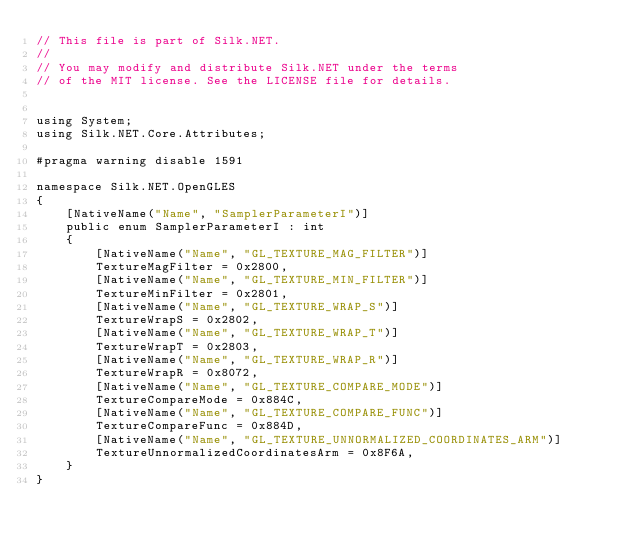<code> <loc_0><loc_0><loc_500><loc_500><_C#_>// This file is part of Silk.NET.
// 
// You may modify and distribute Silk.NET under the terms
// of the MIT license. See the LICENSE file for details.


using System;
using Silk.NET.Core.Attributes;

#pragma warning disable 1591

namespace Silk.NET.OpenGLES
{
    [NativeName("Name", "SamplerParameterI")]
    public enum SamplerParameterI : int
    {
        [NativeName("Name", "GL_TEXTURE_MAG_FILTER")]
        TextureMagFilter = 0x2800,
        [NativeName("Name", "GL_TEXTURE_MIN_FILTER")]
        TextureMinFilter = 0x2801,
        [NativeName("Name", "GL_TEXTURE_WRAP_S")]
        TextureWrapS = 0x2802,
        [NativeName("Name", "GL_TEXTURE_WRAP_T")]
        TextureWrapT = 0x2803,
        [NativeName("Name", "GL_TEXTURE_WRAP_R")]
        TextureWrapR = 0x8072,
        [NativeName("Name", "GL_TEXTURE_COMPARE_MODE")]
        TextureCompareMode = 0x884C,
        [NativeName("Name", "GL_TEXTURE_COMPARE_FUNC")]
        TextureCompareFunc = 0x884D,
        [NativeName("Name", "GL_TEXTURE_UNNORMALIZED_COORDINATES_ARM")]
        TextureUnnormalizedCoordinatesArm = 0x8F6A,
    }
}
</code> 